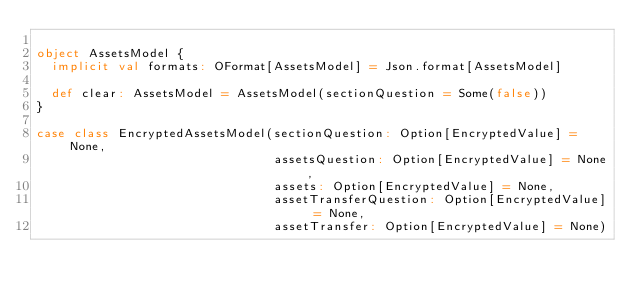Convert code to text. <code><loc_0><loc_0><loc_500><loc_500><_Scala_>
object AssetsModel {
  implicit val formats: OFormat[AssetsModel] = Json.format[AssetsModel]

  def clear: AssetsModel = AssetsModel(sectionQuestion = Some(false))
}

case class EncryptedAssetsModel(sectionQuestion: Option[EncryptedValue] = None,
                                assetsQuestion: Option[EncryptedValue] = None,
                                assets: Option[EncryptedValue] = None,
                                assetTransferQuestion: Option[EncryptedValue] = None,
                                assetTransfer: Option[EncryptedValue] = None)
</code> 